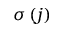Convert formula to latex. <formula><loc_0><loc_0><loc_500><loc_500>\sigma \left ( j \right )</formula> 